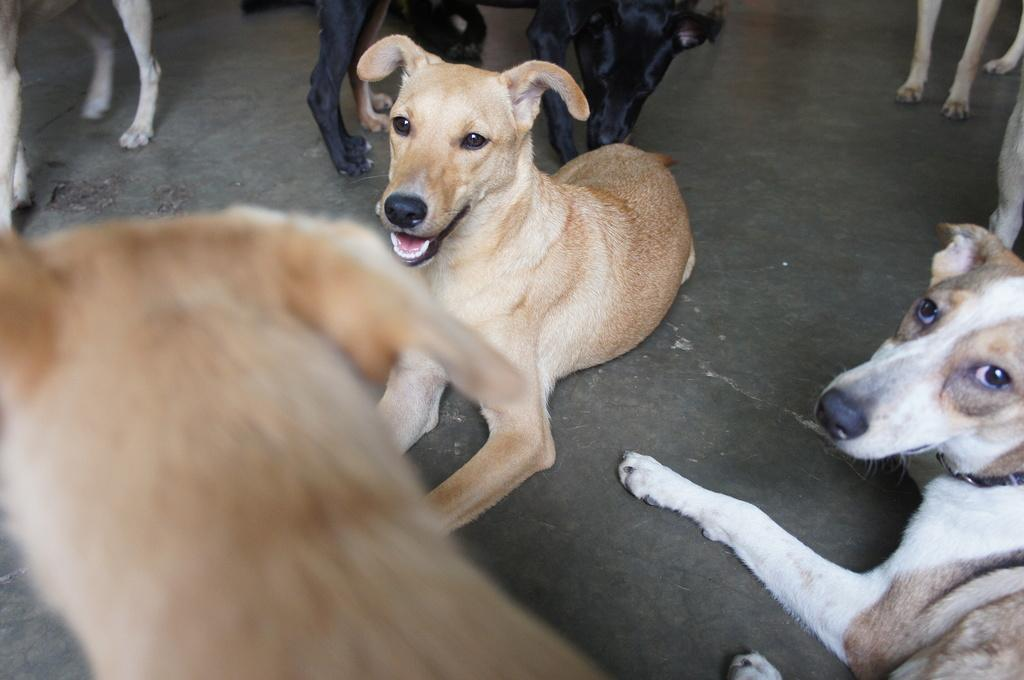What type of animals can be seen in the image? There are many dogs in the image. Can you describe the number of dogs in the image? There are multiple dogs in the image. What might the dogs be doing in the image? The specific actions of the dogs cannot be determined from the provided facts. What type of battle is taking place between the dogs in the image? There is no battle present in the image; it features many dogs, but their actions cannot be determined from the provided facts. 